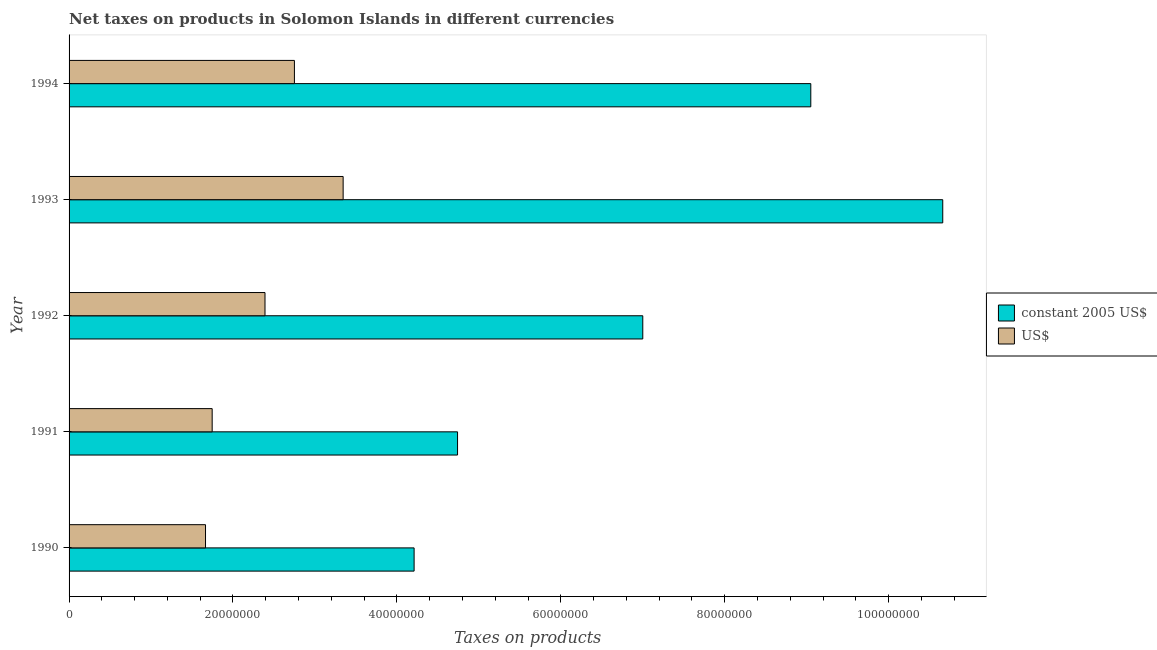How many different coloured bars are there?
Your answer should be compact. 2. Are the number of bars per tick equal to the number of legend labels?
Keep it short and to the point. Yes. Are the number of bars on each tick of the Y-axis equal?
Your response must be concise. Yes. How many bars are there on the 2nd tick from the top?
Give a very brief answer. 2. What is the label of the 4th group of bars from the top?
Your answer should be compact. 1991. In how many cases, is the number of bars for a given year not equal to the number of legend labels?
Provide a short and direct response. 0. What is the net taxes in us$ in 1991?
Make the answer very short. 1.75e+07. Across all years, what is the maximum net taxes in constant 2005 us$?
Provide a short and direct response. 1.07e+08. Across all years, what is the minimum net taxes in us$?
Offer a very short reply. 1.66e+07. In which year was the net taxes in us$ maximum?
Keep it short and to the point. 1993. In which year was the net taxes in constant 2005 us$ minimum?
Ensure brevity in your answer.  1990. What is the total net taxes in us$ in the graph?
Give a very brief answer. 1.19e+08. What is the difference between the net taxes in us$ in 1991 and that in 1993?
Your answer should be compact. -1.60e+07. What is the difference between the net taxes in constant 2005 us$ in 1991 and the net taxes in us$ in 1994?
Offer a very short reply. 1.99e+07. What is the average net taxes in us$ per year?
Offer a terse response. 2.38e+07. In the year 1990, what is the difference between the net taxes in constant 2005 us$ and net taxes in us$?
Make the answer very short. 2.55e+07. What is the ratio of the net taxes in us$ in 1991 to that in 1994?
Make the answer very short. 0.64. Is the difference between the net taxes in constant 2005 us$ in 1992 and 1993 greater than the difference between the net taxes in us$ in 1992 and 1993?
Make the answer very short. No. What is the difference between the highest and the second highest net taxes in constant 2005 us$?
Provide a short and direct response. 1.61e+07. What is the difference between the highest and the lowest net taxes in us$?
Your answer should be compact. 1.68e+07. In how many years, is the net taxes in us$ greater than the average net taxes in us$ taken over all years?
Ensure brevity in your answer.  3. Is the sum of the net taxes in us$ in 1992 and 1993 greater than the maximum net taxes in constant 2005 us$ across all years?
Ensure brevity in your answer.  No. What does the 1st bar from the top in 1990 represents?
Provide a succinct answer. US$. What does the 2nd bar from the bottom in 1992 represents?
Provide a short and direct response. US$. Are all the bars in the graph horizontal?
Give a very brief answer. Yes. How many years are there in the graph?
Provide a short and direct response. 5. What is the difference between two consecutive major ticks on the X-axis?
Your response must be concise. 2.00e+07. Are the values on the major ticks of X-axis written in scientific E-notation?
Make the answer very short. No. Does the graph contain any zero values?
Offer a terse response. No. Does the graph contain grids?
Ensure brevity in your answer.  No. Where does the legend appear in the graph?
Make the answer very short. Center right. How are the legend labels stacked?
Give a very brief answer. Vertical. What is the title of the graph?
Make the answer very short. Net taxes on products in Solomon Islands in different currencies. Does "Secondary Education" appear as one of the legend labels in the graph?
Your answer should be very brief. No. What is the label or title of the X-axis?
Your response must be concise. Taxes on products. What is the label or title of the Y-axis?
Give a very brief answer. Year. What is the Taxes on products of constant 2005 US$ in 1990?
Ensure brevity in your answer.  4.21e+07. What is the Taxes on products in US$ in 1990?
Make the answer very short. 1.66e+07. What is the Taxes on products of constant 2005 US$ in 1991?
Keep it short and to the point. 4.74e+07. What is the Taxes on products in US$ in 1991?
Provide a succinct answer. 1.75e+07. What is the Taxes on products in constant 2005 US$ in 1992?
Your answer should be very brief. 7.00e+07. What is the Taxes on products of US$ in 1992?
Provide a succinct answer. 2.39e+07. What is the Taxes on products in constant 2005 US$ in 1993?
Provide a short and direct response. 1.07e+08. What is the Taxes on products in US$ in 1993?
Your answer should be very brief. 3.34e+07. What is the Taxes on products in constant 2005 US$ in 1994?
Offer a terse response. 9.05e+07. What is the Taxes on products of US$ in 1994?
Ensure brevity in your answer.  2.75e+07. Across all years, what is the maximum Taxes on products of constant 2005 US$?
Your answer should be compact. 1.07e+08. Across all years, what is the maximum Taxes on products of US$?
Keep it short and to the point. 3.34e+07. Across all years, what is the minimum Taxes on products of constant 2005 US$?
Your answer should be very brief. 4.21e+07. Across all years, what is the minimum Taxes on products in US$?
Your response must be concise. 1.66e+07. What is the total Taxes on products in constant 2005 US$ in the graph?
Ensure brevity in your answer.  3.57e+08. What is the total Taxes on products in US$ in the graph?
Make the answer very short. 1.19e+08. What is the difference between the Taxes on products of constant 2005 US$ in 1990 and that in 1991?
Keep it short and to the point. -5.30e+06. What is the difference between the Taxes on products of US$ in 1990 and that in 1991?
Your answer should be very brief. -8.12e+05. What is the difference between the Taxes on products of constant 2005 US$ in 1990 and that in 1992?
Ensure brevity in your answer.  -2.79e+07. What is the difference between the Taxes on products in US$ in 1990 and that in 1992?
Offer a terse response. -7.26e+06. What is the difference between the Taxes on products in constant 2005 US$ in 1990 and that in 1993?
Provide a succinct answer. -6.45e+07. What is the difference between the Taxes on products in US$ in 1990 and that in 1993?
Ensure brevity in your answer.  -1.68e+07. What is the difference between the Taxes on products in constant 2005 US$ in 1990 and that in 1994?
Ensure brevity in your answer.  -4.84e+07. What is the difference between the Taxes on products in US$ in 1990 and that in 1994?
Keep it short and to the point. -1.08e+07. What is the difference between the Taxes on products of constant 2005 US$ in 1991 and that in 1992?
Make the answer very short. -2.26e+07. What is the difference between the Taxes on products in US$ in 1991 and that in 1992?
Give a very brief answer. -6.45e+06. What is the difference between the Taxes on products of constant 2005 US$ in 1991 and that in 1993?
Offer a terse response. -5.92e+07. What is the difference between the Taxes on products in US$ in 1991 and that in 1993?
Provide a succinct answer. -1.60e+07. What is the difference between the Taxes on products of constant 2005 US$ in 1991 and that in 1994?
Your response must be concise. -4.31e+07. What is the difference between the Taxes on products of US$ in 1991 and that in 1994?
Give a very brief answer. -1.00e+07. What is the difference between the Taxes on products of constant 2005 US$ in 1992 and that in 1993?
Provide a short and direct response. -3.66e+07. What is the difference between the Taxes on products of US$ in 1992 and that in 1993?
Provide a short and direct response. -9.53e+06. What is the difference between the Taxes on products in constant 2005 US$ in 1992 and that in 1994?
Give a very brief answer. -2.05e+07. What is the difference between the Taxes on products in US$ in 1992 and that in 1994?
Ensure brevity in your answer.  -3.59e+06. What is the difference between the Taxes on products of constant 2005 US$ in 1993 and that in 1994?
Your response must be concise. 1.61e+07. What is the difference between the Taxes on products of US$ in 1993 and that in 1994?
Keep it short and to the point. 5.95e+06. What is the difference between the Taxes on products in constant 2005 US$ in 1990 and the Taxes on products in US$ in 1991?
Your answer should be compact. 2.46e+07. What is the difference between the Taxes on products of constant 2005 US$ in 1990 and the Taxes on products of US$ in 1992?
Provide a short and direct response. 1.82e+07. What is the difference between the Taxes on products of constant 2005 US$ in 1990 and the Taxes on products of US$ in 1993?
Your answer should be very brief. 8.66e+06. What is the difference between the Taxes on products in constant 2005 US$ in 1990 and the Taxes on products in US$ in 1994?
Ensure brevity in your answer.  1.46e+07. What is the difference between the Taxes on products of constant 2005 US$ in 1991 and the Taxes on products of US$ in 1992?
Offer a very short reply. 2.35e+07. What is the difference between the Taxes on products of constant 2005 US$ in 1991 and the Taxes on products of US$ in 1993?
Ensure brevity in your answer.  1.40e+07. What is the difference between the Taxes on products in constant 2005 US$ in 1991 and the Taxes on products in US$ in 1994?
Your answer should be compact. 1.99e+07. What is the difference between the Taxes on products of constant 2005 US$ in 1992 and the Taxes on products of US$ in 1993?
Your answer should be very brief. 3.66e+07. What is the difference between the Taxes on products of constant 2005 US$ in 1992 and the Taxes on products of US$ in 1994?
Your answer should be compact. 4.25e+07. What is the difference between the Taxes on products of constant 2005 US$ in 1993 and the Taxes on products of US$ in 1994?
Your response must be concise. 7.91e+07. What is the average Taxes on products of constant 2005 US$ per year?
Offer a terse response. 7.13e+07. What is the average Taxes on products in US$ per year?
Provide a succinct answer. 2.38e+07. In the year 1990, what is the difference between the Taxes on products in constant 2005 US$ and Taxes on products in US$?
Offer a very short reply. 2.55e+07. In the year 1991, what is the difference between the Taxes on products in constant 2005 US$ and Taxes on products in US$?
Your response must be concise. 2.99e+07. In the year 1992, what is the difference between the Taxes on products of constant 2005 US$ and Taxes on products of US$?
Provide a short and direct response. 4.61e+07. In the year 1993, what is the difference between the Taxes on products of constant 2005 US$ and Taxes on products of US$?
Keep it short and to the point. 7.32e+07. In the year 1994, what is the difference between the Taxes on products in constant 2005 US$ and Taxes on products in US$?
Your answer should be compact. 6.30e+07. What is the ratio of the Taxes on products in constant 2005 US$ in 1990 to that in 1991?
Provide a succinct answer. 0.89. What is the ratio of the Taxes on products in US$ in 1990 to that in 1991?
Keep it short and to the point. 0.95. What is the ratio of the Taxes on products in constant 2005 US$ in 1990 to that in 1992?
Ensure brevity in your answer.  0.6. What is the ratio of the Taxes on products of US$ in 1990 to that in 1992?
Your answer should be compact. 0.7. What is the ratio of the Taxes on products of constant 2005 US$ in 1990 to that in 1993?
Offer a terse response. 0.39. What is the ratio of the Taxes on products of US$ in 1990 to that in 1993?
Offer a terse response. 0.5. What is the ratio of the Taxes on products in constant 2005 US$ in 1990 to that in 1994?
Offer a terse response. 0.47. What is the ratio of the Taxes on products of US$ in 1990 to that in 1994?
Provide a succinct answer. 0.61. What is the ratio of the Taxes on products in constant 2005 US$ in 1991 to that in 1992?
Offer a very short reply. 0.68. What is the ratio of the Taxes on products in US$ in 1991 to that in 1992?
Your answer should be very brief. 0.73. What is the ratio of the Taxes on products of constant 2005 US$ in 1991 to that in 1993?
Provide a succinct answer. 0.44. What is the ratio of the Taxes on products of US$ in 1991 to that in 1993?
Make the answer very short. 0.52. What is the ratio of the Taxes on products in constant 2005 US$ in 1991 to that in 1994?
Provide a short and direct response. 0.52. What is the ratio of the Taxes on products in US$ in 1991 to that in 1994?
Your answer should be compact. 0.64. What is the ratio of the Taxes on products of constant 2005 US$ in 1992 to that in 1993?
Keep it short and to the point. 0.66. What is the ratio of the Taxes on products in US$ in 1992 to that in 1993?
Ensure brevity in your answer.  0.71. What is the ratio of the Taxes on products of constant 2005 US$ in 1992 to that in 1994?
Your response must be concise. 0.77. What is the ratio of the Taxes on products of US$ in 1992 to that in 1994?
Your answer should be very brief. 0.87. What is the ratio of the Taxes on products of constant 2005 US$ in 1993 to that in 1994?
Offer a terse response. 1.18. What is the ratio of the Taxes on products of US$ in 1993 to that in 1994?
Provide a succinct answer. 1.22. What is the difference between the highest and the second highest Taxes on products of constant 2005 US$?
Your answer should be very brief. 1.61e+07. What is the difference between the highest and the second highest Taxes on products in US$?
Offer a terse response. 5.95e+06. What is the difference between the highest and the lowest Taxes on products in constant 2005 US$?
Make the answer very short. 6.45e+07. What is the difference between the highest and the lowest Taxes on products of US$?
Provide a short and direct response. 1.68e+07. 